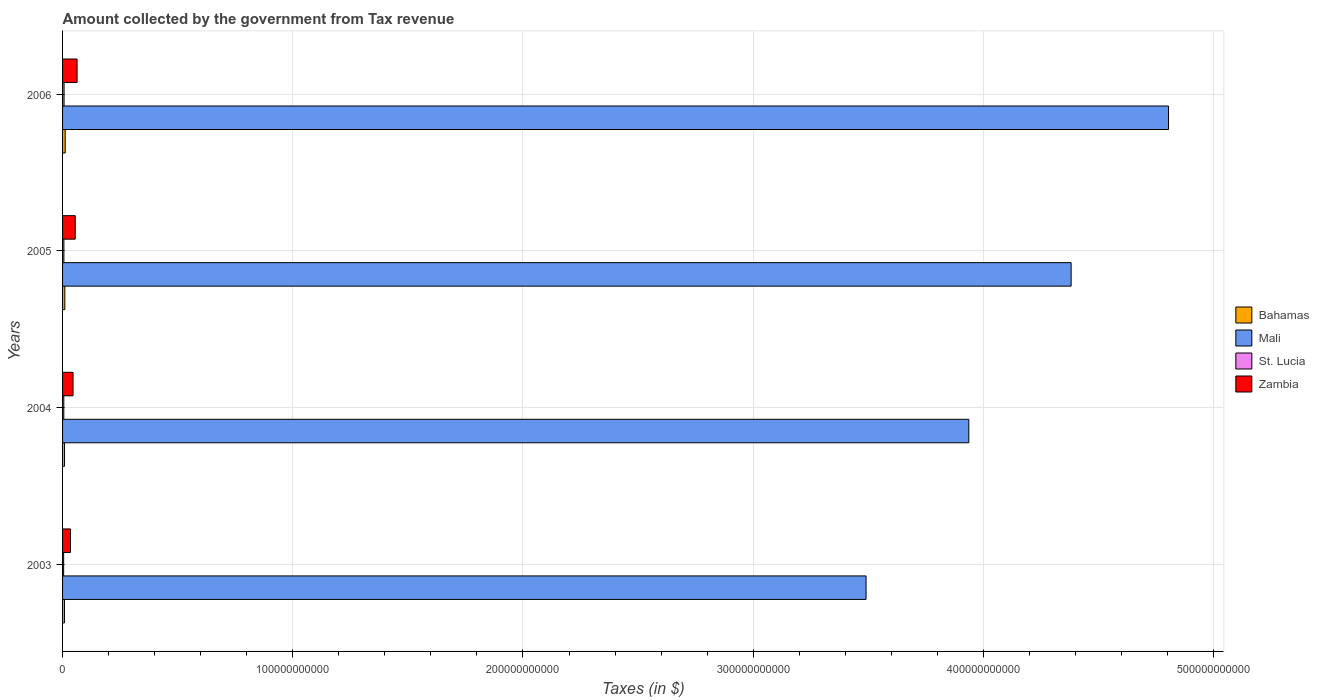Are the number of bars per tick equal to the number of legend labels?
Keep it short and to the point. Yes. How many bars are there on the 4th tick from the top?
Your answer should be very brief. 4. How many bars are there on the 1st tick from the bottom?
Keep it short and to the point. 4. What is the label of the 1st group of bars from the top?
Offer a very short reply. 2006. In how many cases, is the number of bars for a given year not equal to the number of legend labels?
Ensure brevity in your answer.  0. What is the amount collected by the government from tax revenue in Zambia in 2003?
Keep it short and to the point. 3.45e+09. Across all years, what is the maximum amount collected by the government from tax revenue in Bahamas?
Offer a terse response. 1.14e+09. Across all years, what is the minimum amount collected by the government from tax revenue in Zambia?
Your response must be concise. 3.45e+09. In which year was the amount collected by the government from tax revenue in St. Lucia maximum?
Provide a succinct answer. 2006. In which year was the amount collected by the government from tax revenue in Bahamas minimum?
Make the answer very short. 2003. What is the total amount collected by the government from tax revenue in Zambia in the graph?
Provide a short and direct response. 1.98e+1. What is the difference between the amount collected by the government from tax revenue in Bahamas in 2003 and that in 2006?
Your answer should be very brief. -3.20e+08. What is the difference between the amount collected by the government from tax revenue in Mali in 2006 and the amount collected by the government from tax revenue in Bahamas in 2005?
Make the answer very short. 4.79e+11. What is the average amount collected by the government from tax revenue in St. Lucia per year?
Offer a very short reply. 5.57e+08. In the year 2005, what is the difference between the amount collected by the government from tax revenue in Mali and amount collected by the government from tax revenue in Zambia?
Ensure brevity in your answer.  4.33e+11. In how many years, is the amount collected by the government from tax revenue in St. Lucia greater than 380000000000 $?
Your answer should be compact. 0. What is the ratio of the amount collected by the government from tax revenue in Mali in 2003 to that in 2006?
Offer a terse response. 0.73. Is the amount collected by the government from tax revenue in Zambia in 2003 less than that in 2005?
Give a very brief answer. Yes. Is the difference between the amount collected by the government from tax revenue in Mali in 2004 and 2005 greater than the difference between the amount collected by the government from tax revenue in Zambia in 2004 and 2005?
Ensure brevity in your answer.  No. What is the difference between the highest and the second highest amount collected by the government from tax revenue in Bahamas?
Give a very brief answer. 1.60e+08. What is the difference between the highest and the lowest amount collected by the government from tax revenue in Zambia?
Offer a terse response. 2.85e+09. In how many years, is the amount collected by the government from tax revenue in Mali greater than the average amount collected by the government from tax revenue in Mali taken over all years?
Make the answer very short. 2. What does the 1st bar from the top in 2003 represents?
Provide a short and direct response. Zambia. What does the 3rd bar from the bottom in 2006 represents?
Your response must be concise. St. Lucia. Is it the case that in every year, the sum of the amount collected by the government from tax revenue in St. Lucia and amount collected by the government from tax revenue in Mali is greater than the amount collected by the government from tax revenue in Zambia?
Your answer should be compact. Yes. How many years are there in the graph?
Keep it short and to the point. 4. What is the difference between two consecutive major ticks on the X-axis?
Your response must be concise. 1.00e+11. Are the values on the major ticks of X-axis written in scientific E-notation?
Your answer should be very brief. No. Where does the legend appear in the graph?
Your response must be concise. Center right. What is the title of the graph?
Give a very brief answer. Amount collected by the government from Tax revenue. What is the label or title of the X-axis?
Ensure brevity in your answer.  Taxes (in $). What is the label or title of the Y-axis?
Make the answer very short. Years. What is the Taxes (in $) in Bahamas in 2003?
Make the answer very short. 8.24e+08. What is the Taxes (in $) of Mali in 2003?
Ensure brevity in your answer.  3.49e+11. What is the Taxes (in $) in St. Lucia in 2003?
Your response must be concise. 4.67e+08. What is the Taxes (in $) of Zambia in 2003?
Keep it short and to the point. 3.45e+09. What is the Taxes (in $) in Bahamas in 2004?
Provide a succinct answer. 8.54e+08. What is the Taxes (in $) in Mali in 2004?
Provide a short and direct response. 3.94e+11. What is the Taxes (in $) of St. Lucia in 2004?
Your answer should be very brief. 5.38e+08. What is the Taxes (in $) of Zambia in 2004?
Your answer should be very brief. 4.55e+09. What is the Taxes (in $) in Bahamas in 2005?
Make the answer very short. 9.84e+08. What is the Taxes (in $) in Mali in 2005?
Provide a succinct answer. 4.38e+11. What is the Taxes (in $) in St. Lucia in 2005?
Your response must be concise. 5.77e+08. What is the Taxes (in $) in Zambia in 2005?
Keep it short and to the point. 5.50e+09. What is the Taxes (in $) in Bahamas in 2006?
Offer a terse response. 1.14e+09. What is the Taxes (in $) in Mali in 2006?
Provide a succinct answer. 4.80e+11. What is the Taxes (in $) in St. Lucia in 2006?
Ensure brevity in your answer.  6.48e+08. What is the Taxes (in $) in Zambia in 2006?
Provide a short and direct response. 6.30e+09. Across all years, what is the maximum Taxes (in $) of Bahamas?
Provide a short and direct response. 1.14e+09. Across all years, what is the maximum Taxes (in $) in Mali?
Your response must be concise. 4.80e+11. Across all years, what is the maximum Taxes (in $) in St. Lucia?
Give a very brief answer. 6.48e+08. Across all years, what is the maximum Taxes (in $) in Zambia?
Make the answer very short. 6.30e+09. Across all years, what is the minimum Taxes (in $) in Bahamas?
Your response must be concise. 8.24e+08. Across all years, what is the minimum Taxes (in $) in Mali?
Give a very brief answer. 3.49e+11. Across all years, what is the minimum Taxes (in $) of St. Lucia?
Keep it short and to the point. 4.67e+08. Across all years, what is the minimum Taxes (in $) of Zambia?
Your response must be concise. 3.45e+09. What is the total Taxes (in $) of Bahamas in the graph?
Keep it short and to the point. 3.81e+09. What is the total Taxes (in $) of Mali in the graph?
Keep it short and to the point. 1.66e+12. What is the total Taxes (in $) in St. Lucia in the graph?
Your response must be concise. 2.23e+09. What is the total Taxes (in $) of Zambia in the graph?
Offer a very short reply. 1.98e+1. What is the difference between the Taxes (in $) of Bahamas in 2003 and that in 2004?
Offer a very short reply. -2.99e+07. What is the difference between the Taxes (in $) in Mali in 2003 and that in 2004?
Offer a terse response. -4.46e+1. What is the difference between the Taxes (in $) in St. Lucia in 2003 and that in 2004?
Make the answer very short. -7.13e+07. What is the difference between the Taxes (in $) of Zambia in 2003 and that in 2004?
Give a very brief answer. -1.11e+09. What is the difference between the Taxes (in $) in Bahamas in 2003 and that in 2005?
Your response must be concise. -1.60e+08. What is the difference between the Taxes (in $) of Mali in 2003 and that in 2005?
Your answer should be compact. -8.91e+1. What is the difference between the Taxes (in $) in St. Lucia in 2003 and that in 2005?
Provide a short and direct response. -1.10e+08. What is the difference between the Taxes (in $) of Zambia in 2003 and that in 2005?
Offer a terse response. -2.05e+09. What is the difference between the Taxes (in $) in Bahamas in 2003 and that in 2006?
Ensure brevity in your answer.  -3.20e+08. What is the difference between the Taxes (in $) in Mali in 2003 and that in 2006?
Offer a terse response. -1.31e+11. What is the difference between the Taxes (in $) in St. Lucia in 2003 and that in 2006?
Keep it short and to the point. -1.81e+08. What is the difference between the Taxes (in $) in Zambia in 2003 and that in 2006?
Keep it short and to the point. -2.85e+09. What is the difference between the Taxes (in $) of Bahamas in 2004 and that in 2005?
Offer a terse response. -1.30e+08. What is the difference between the Taxes (in $) of Mali in 2004 and that in 2005?
Provide a succinct answer. -4.44e+1. What is the difference between the Taxes (in $) of St. Lucia in 2004 and that in 2005?
Give a very brief answer. -3.90e+07. What is the difference between the Taxes (in $) in Zambia in 2004 and that in 2005?
Give a very brief answer. -9.48e+08. What is the difference between the Taxes (in $) in Bahamas in 2004 and that in 2006?
Offer a very short reply. -2.90e+08. What is the difference between the Taxes (in $) in Mali in 2004 and that in 2006?
Your answer should be very brief. -8.68e+1. What is the difference between the Taxes (in $) of St. Lucia in 2004 and that in 2006?
Provide a succinct answer. -1.10e+08. What is the difference between the Taxes (in $) in Zambia in 2004 and that in 2006?
Keep it short and to the point. -1.75e+09. What is the difference between the Taxes (in $) in Bahamas in 2005 and that in 2006?
Your answer should be compact. -1.60e+08. What is the difference between the Taxes (in $) of Mali in 2005 and that in 2006?
Ensure brevity in your answer.  -4.23e+1. What is the difference between the Taxes (in $) in St. Lucia in 2005 and that in 2006?
Make the answer very short. -7.09e+07. What is the difference between the Taxes (in $) of Zambia in 2005 and that in 2006?
Provide a short and direct response. -8.00e+08. What is the difference between the Taxes (in $) in Bahamas in 2003 and the Taxes (in $) in Mali in 2004?
Offer a terse response. -3.93e+11. What is the difference between the Taxes (in $) in Bahamas in 2003 and the Taxes (in $) in St. Lucia in 2004?
Provide a succinct answer. 2.86e+08. What is the difference between the Taxes (in $) in Bahamas in 2003 and the Taxes (in $) in Zambia in 2004?
Provide a succinct answer. -3.73e+09. What is the difference between the Taxes (in $) of Mali in 2003 and the Taxes (in $) of St. Lucia in 2004?
Provide a succinct answer. 3.48e+11. What is the difference between the Taxes (in $) in Mali in 2003 and the Taxes (in $) in Zambia in 2004?
Make the answer very short. 3.44e+11. What is the difference between the Taxes (in $) of St. Lucia in 2003 and the Taxes (in $) of Zambia in 2004?
Your answer should be very brief. -4.09e+09. What is the difference between the Taxes (in $) of Bahamas in 2003 and the Taxes (in $) of Mali in 2005?
Offer a very short reply. -4.37e+11. What is the difference between the Taxes (in $) of Bahamas in 2003 and the Taxes (in $) of St. Lucia in 2005?
Your response must be concise. 2.47e+08. What is the difference between the Taxes (in $) of Bahamas in 2003 and the Taxes (in $) of Zambia in 2005?
Your answer should be very brief. -4.68e+09. What is the difference between the Taxes (in $) in Mali in 2003 and the Taxes (in $) in St. Lucia in 2005?
Your response must be concise. 3.48e+11. What is the difference between the Taxes (in $) in Mali in 2003 and the Taxes (in $) in Zambia in 2005?
Your answer should be very brief. 3.44e+11. What is the difference between the Taxes (in $) of St. Lucia in 2003 and the Taxes (in $) of Zambia in 2005?
Your answer should be compact. -5.04e+09. What is the difference between the Taxes (in $) in Bahamas in 2003 and the Taxes (in $) in Mali in 2006?
Make the answer very short. -4.80e+11. What is the difference between the Taxes (in $) of Bahamas in 2003 and the Taxes (in $) of St. Lucia in 2006?
Provide a succinct answer. 1.76e+08. What is the difference between the Taxes (in $) of Bahamas in 2003 and the Taxes (in $) of Zambia in 2006?
Keep it short and to the point. -5.48e+09. What is the difference between the Taxes (in $) of Mali in 2003 and the Taxes (in $) of St. Lucia in 2006?
Keep it short and to the point. 3.48e+11. What is the difference between the Taxes (in $) in Mali in 2003 and the Taxes (in $) in Zambia in 2006?
Provide a succinct answer. 3.43e+11. What is the difference between the Taxes (in $) of St. Lucia in 2003 and the Taxes (in $) of Zambia in 2006?
Provide a short and direct response. -5.84e+09. What is the difference between the Taxes (in $) of Bahamas in 2004 and the Taxes (in $) of Mali in 2005?
Make the answer very short. -4.37e+11. What is the difference between the Taxes (in $) in Bahamas in 2004 and the Taxes (in $) in St. Lucia in 2005?
Your answer should be very brief. 2.77e+08. What is the difference between the Taxes (in $) in Bahamas in 2004 and the Taxes (in $) in Zambia in 2005?
Offer a very short reply. -4.65e+09. What is the difference between the Taxes (in $) in Mali in 2004 and the Taxes (in $) in St. Lucia in 2005?
Your answer should be very brief. 3.93e+11. What is the difference between the Taxes (in $) in Mali in 2004 and the Taxes (in $) in Zambia in 2005?
Offer a very short reply. 3.88e+11. What is the difference between the Taxes (in $) of St. Lucia in 2004 and the Taxes (in $) of Zambia in 2005?
Offer a very short reply. -4.96e+09. What is the difference between the Taxes (in $) in Bahamas in 2004 and the Taxes (in $) in Mali in 2006?
Keep it short and to the point. -4.80e+11. What is the difference between the Taxes (in $) of Bahamas in 2004 and the Taxes (in $) of St. Lucia in 2006?
Provide a short and direct response. 2.06e+08. What is the difference between the Taxes (in $) in Bahamas in 2004 and the Taxes (in $) in Zambia in 2006?
Your answer should be very brief. -5.45e+09. What is the difference between the Taxes (in $) in Mali in 2004 and the Taxes (in $) in St. Lucia in 2006?
Offer a very short reply. 3.93e+11. What is the difference between the Taxes (in $) in Mali in 2004 and the Taxes (in $) in Zambia in 2006?
Make the answer very short. 3.87e+11. What is the difference between the Taxes (in $) in St. Lucia in 2004 and the Taxes (in $) in Zambia in 2006?
Ensure brevity in your answer.  -5.76e+09. What is the difference between the Taxes (in $) of Bahamas in 2005 and the Taxes (in $) of Mali in 2006?
Provide a short and direct response. -4.79e+11. What is the difference between the Taxes (in $) of Bahamas in 2005 and the Taxes (in $) of St. Lucia in 2006?
Your response must be concise. 3.36e+08. What is the difference between the Taxes (in $) in Bahamas in 2005 and the Taxes (in $) in Zambia in 2006?
Your response must be concise. -5.32e+09. What is the difference between the Taxes (in $) in Mali in 2005 and the Taxes (in $) in St. Lucia in 2006?
Provide a succinct answer. 4.37e+11. What is the difference between the Taxes (in $) of Mali in 2005 and the Taxes (in $) of Zambia in 2006?
Provide a succinct answer. 4.32e+11. What is the difference between the Taxes (in $) of St. Lucia in 2005 and the Taxes (in $) of Zambia in 2006?
Make the answer very short. -5.73e+09. What is the average Taxes (in $) in Bahamas per year?
Keep it short and to the point. 9.51e+08. What is the average Taxes (in $) of Mali per year?
Your answer should be compact. 4.15e+11. What is the average Taxes (in $) in St. Lucia per year?
Keep it short and to the point. 5.57e+08. What is the average Taxes (in $) of Zambia per year?
Provide a succinct answer. 4.95e+09. In the year 2003, what is the difference between the Taxes (in $) of Bahamas and Taxes (in $) of Mali?
Ensure brevity in your answer.  -3.48e+11. In the year 2003, what is the difference between the Taxes (in $) of Bahamas and Taxes (in $) of St. Lucia?
Offer a terse response. 3.57e+08. In the year 2003, what is the difference between the Taxes (in $) in Bahamas and Taxes (in $) in Zambia?
Provide a short and direct response. -2.62e+09. In the year 2003, what is the difference between the Taxes (in $) of Mali and Taxes (in $) of St. Lucia?
Offer a very short reply. 3.49e+11. In the year 2003, what is the difference between the Taxes (in $) of Mali and Taxes (in $) of Zambia?
Your response must be concise. 3.46e+11. In the year 2003, what is the difference between the Taxes (in $) in St. Lucia and Taxes (in $) in Zambia?
Make the answer very short. -2.98e+09. In the year 2004, what is the difference between the Taxes (in $) in Bahamas and Taxes (in $) in Mali?
Provide a short and direct response. -3.93e+11. In the year 2004, what is the difference between the Taxes (in $) of Bahamas and Taxes (in $) of St. Lucia?
Provide a succinct answer. 3.16e+08. In the year 2004, what is the difference between the Taxes (in $) of Bahamas and Taxes (in $) of Zambia?
Offer a terse response. -3.70e+09. In the year 2004, what is the difference between the Taxes (in $) of Mali and Taxes (in $) of St. Lucia?
Offer a very short reply. 3.93e+11. In the year 2004, what is the difference between the Taxes (in $) in Mali and Taxes (in $) in Zambia?
Make the answer very short. 3.89e+11. In the year 2004, what is the difference between the Taxes (in $) in St. Lucia and Taxes (in $) in Zambia?
Keep it short and to the point. -4.02e+09. In the year 2005, what is the difference between the Taxes (in $) of Bahamas and Taxes (in $) of Mali?
Offer a terse response. -4.37e+11. In the year 2005, what is the difference between the Taxes (in $) in Bahamas and Taxes (in $) in St. Lucia?
Provide a succinct answer. 4.07e+08. In the year 2005, what is the difference between the Taxes (in $) in Bahamas and Taxes (in $) in Zambia?
Your response must be concise. -4.52e+09. In the year 2005, what is the difference between the Taxes (in $) in Mali and Taxes (in $) in St. Lucia?
Offer a terse response. 4.38e+11. In the year 2005, what is the difference between the Taxes (in $) in Mali and Taxes (in $) in Zambia?
Offer a terse response. 4.33e+11. In the year 2005, what is the difference between the Taxes (in $) in St. Lucia and Taxes (in $) in Zambia?
Make the answer very short. -4.93e+09. In the year 2006, what is the difference between the Taxes (in $) of Bahamas and Taxes (in $) of Mali?
Provide a short and direct response. -4.79e+11. In the year 2006, what is the difference between the Taxes (in $) of Bahamas and Taxes (in $) of St. Lucia?
Offer a terse response. 4.96e+08. In the year 2006, what is the difference between the Taxes (in $) of Bahamas and Taxes (in $) of Zambia?
Your answer should be compact. -5.16e+09. In the year 2006, what is the difference between the Taxes (in $) of Mali and Taxes (in $) of St. Lucia?
Give a very brief answer. 4.80e+11. In the year 2006, what is the difference between the Taxes (in $) of Mali and Taxes (in $) of Zambia?
Ensure brevity in your answer.  4.74e+11. In the year 2006, what is the difference between the Taxes (in $) of St. Lucia and Taxes (in $) of Zambia?
Make the answer very short. -5.65e+09. What is the ratio of the Taxes (in $) in Bahamas in 2003 to that in 2004?
Provide a short and direct response. 0.96. What is the ratio of the Taxes (in $) in Mali in 2003 to that in 2004?
Provide a succinct answer. 0.89. What is the ratio of the Taxes (in $) in St. Lucia in 2003 to that in 2004?
Offer a terse response. 0.87. What is the ratio of the Taxes (in $) of Zambia in 2003 to that in 2004?
Your response must be concise. 0.76. What is the ratio of the Taxes (in $) of Bahamas in 2003 to that in 2005?
Offer a terse response. 0.84. What is the ratio of the Taxes (in $) of Mali in 2003 to that in 2005?
Your answer should be compact. 0.8. What is the ratio of the Taxes (in $) in St. Lucia in 2003 to that in 2005?
Ensure brevity in your answer.  0.81. What is the ratio of the Taxes (in $) of Zambia in 2003 to that in 2005?
Provide a short and direct response. 0.63. What is the ratio of the Taxes (in $) of Bahamas in 2003 to that in 2006?
Ensure brevity in your answer.  0.72. What is the ratio of the Taxes (in $) in Mali in 2003 to that in 2006?
Provide a succinct answer. 0.73. What is the ratio of the Taxes (in $) of St. Lucia in 2003 to that in 2006?
Offer a very short reply. 0.72. What is the ratio of the Taxes (in $) in Zambia in 2003 to that in 2006?
Give a very brief answer. 0.55. What is the ratio of the Taxes (in $) of Bahamas in 2004 to that in 2005?
Provide a succinct answer. 0.87. What is the ratio of the Taxes (in $) of Mali in 2004 to that in 2005?
Offer a very short reply. 0.9. What is the ratio of the Taxes (in $) of St. Lucia in 2004 to that in 2005?
Offer a terse response. 0.93. What is the ratio of the Taxes (in $) of Zambia in 2004 to that in 2005?
Offer a very short reply. 0.83. What is the ratio of the Taxes (in $) of Bahamas in 2004 to that in 2006?
Offer a very short reply. 0.75. What is the ratio of the Taxes (in $) in Mali in 2004 to that in 2006?
Your answer should be very brief. 0.82. What is the ratio of the Taxes (in $) of St. Lucia in 2004 to that in 2006?
Offer a terse response. 0.83. What is the ratio of the Taxes (in $) in Zambia in 2004 to that in 2006?
Provide a succinct answer. 0.72. What is the ratio of the Taxes (in $) in Bahamas in 2005 to that in 2006?
Keep it short and to the point. 0.86. What is the ratio of the Taxes (in $) of Mali in 2005 to that in 2006?
Your response must be concise. 0.91. What is the ratio of the Taxes (in $) in St. Lucia in 2005 to that in 2006?
Provide a short and direct response. 0.89. What is the ratio of the Taxes (in $) of Zambia in 2005 to that in 2006?
Ensure brevity in your answer.  0.87. What is the difference between the highest and the second highest Taxes (in $) of Bahamas?
Your answer should be compact. 1.60e+08. What is the difference between the highest and the second highest Taxes (in $) in Mali?
Make the answer very short. 4.23e+1. What is the difference between the highest and the second highest Taxes (in $) in St. Lucia?
Give a very brief answer. 7.09e+07. What is the difference between the highest and the second highest Taxes (in $) of Zambia?
Your answer should be compact. 8.00e+08. What is the difference between the highest and the lowest Taxes (in $) of Bahamas?
Your response must be concise. 3.20e+08. What is the difference between the highest and the lowest Taxes (in $) of Mali?
Give a very brief answer. 1.31e+11. What is the difference between the highest and the lowest Taxes (in $) in St. Lucia?
Offer a very short reply. 1.81e+08. What is the difference between the highest and the lowest Taxes (in $) of Zambia?
Offer a terse response. 2.85e+09. 